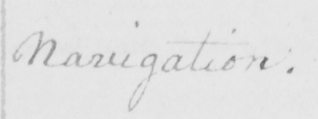What text is written in this handwritten line? Navigation . 